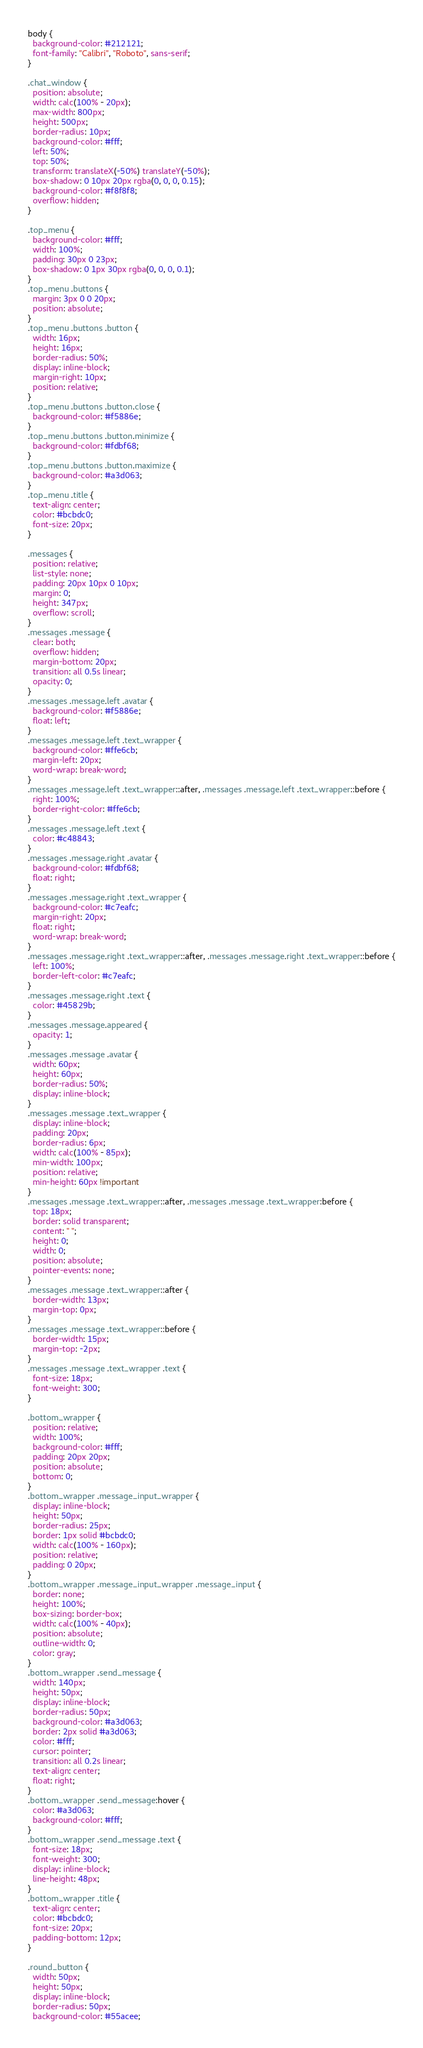Convert code to text. <code><loc_0><loc_0><loc_500><loc_500><_CSS_>body {
  background-color: #212121;
  font-family: "Calibri", "Roboto", sans-serif;
}

.chat_window {
  position: absolute;
  width: calc(100% - 20px);
  max-width: 800px;
  height: 500px;
  border-radius: 10px;
  background-color: #fff;
  left: 50%;
  top: 50%;
  transform: translateX(-50%) translateY(-50%);
  box-shadow: 0 10px 20px rgba(0, 0, 0, 0.15);
  background-color: #f8f8f8;
  overflow: hidden;
}

.top_menu {
  background-color: #fff;
  width: 100%;
  padding: 30px 0 23px;
  box-shadow: 0 1px 30px rgba(0, 0, 0, 0.1);
}
.top_menu .buttons {
  margin: 3px 0 0 20px;
  position: absolute;
}
.top_menu .buttons .button {
  width: 16px;
  height: 16px;
  border-radius: 50%;
  display: inline-block;
  margin-right: 10px;
  position: relative;
}
.top_menu .buttons .button.close {
  background-color: #f5886e;
}
.top_menu .buttons .button.minimize {
  background-color: #fdbf68;
}
.top_menu .buttons .button.maximize {
  background-color: #a3d063;
}
.top_menu .title {
  text-align: center;
  color: #bcbdc0;
  font-size: 20px;
}

.messages {
  position: relative;
  list-style: none;
  padding: 20px 10px 0 10px;
  margin: 0;
  height: 347px;
  overflow: scroll;
}
.messages .message {
  clear: both;
  overflow: hidden;
  margin-bottom: 20px;
  transition: all 0.5s linear;
  opacity: 0;
}
.messages .message.left .avatar {
  background-color: #f5886e;
  float: left;
}
.messages .message.left .text_wrapper {
  background-color: #ffe6cb;
  margin-left: 20px;
  word-wrap: break-word;
}
.messages .message.left .text_wrapper::after, .messages .message.left .text_wrapper::before {
  right: 100%;
  border-right-color: #ffe6cb;
}
.messages .message.left .text {
  color: #c48843;
}
.messages .message.right .avatar {
  background-color: #fdbf68;
  float: right;
}
.messages .message.right .text_wrapper {
  background-color: #c7eafc;
  margin-right: 20px;
  float: right;
  word-wrap: break-word;
}
.messages .message.right .text_wrapper::after, .messages .message.right .text_wrapper::before {
  left: 100%;
  border-left-color: #c7eafc;
}
.messages .message.right .text {
  color: #45829b;
}
.messages .message.appeared {
  opacity: 1;
}
.messages .message .avatar {
  width: 60px;
  height: 60px;
  border-radius: 50%;
  display: inline-block;
}
.messages .message .text_wrapper {
  display: inline-block;
  padding: 20px;
  border-radius: 6px;
  width: calc(100% - 85px);
  min-width: 100px;
  position: relative;
  min-height: 60px !important
}
.messages .message .text_wrapper::after, .messages .message .text_wrapper:before {
  top: 18px;
  border: solid transparent;
  content: " ";
  height: 0;
  width: 0;
  position: absolute;
  pointer-events: none;
}
.messages .message .text_wrapper::after {
  border-width: 13px;
  margin-top: 0px;
}
.messages .message .text_wrapper::before {
  border-width: 15px;
  margin-top: -2px;
}
.messages .message .text_wrapper .text {
  font-size: 18px;
  font-weight: 300;
}

.bottom_wrapper {
  position: relative;
  width: 100%;
  background-color: #fff;
  padding: 20px 20px;
  position: absolute;
  bottom: 0;
}
.bottom_wrapper .message_input_wrapper {
  display: inline-block;
  height: 50px;
  border-radius: 25px;
  border: 1px solid #bcbdc0;
  width: calc(100% - 160px);
  position: relative;
  padding: 0 20px;
}
.bottom_wrapper .message_input_wrapper .message_input {
  border: none;
  height: 100%;
  box-sizing: border-box;
  width: calc(100% - 40px);
  position: absolute;
  outline-width: 0;
  color: gray;
}
.bottom_wrapper .send_message {
  width: 140px;
  height: 50px;
  display: inline-block;
  border-radius: 50px;
  background-color: #a3d063;
  border: 2px solid #a3d063;
  color: #fff;
  cursor: pointer;
  transition: all 0.2s linear;
  text-align: center;
  float: right;
}
.bottom_wrapper .send_message:hover {
  color: #a3d063;
  background-color: #fff;
}
.bottom_wrapper .send_message .text {
  font-size: 18px;
  font-weight: 300;
  display: inline-block;
  line-height: 48px;
}
.bottom_wrapper .title {
  text-align: center;
  color: #bcbdc0;
  font-size: 20px;
  padding-bottom: 12px;
}

.round_button {
  width: 50px;
  height: 50px;
  display: inline-block;
  border-radius: 50px;
  background-color: #55acee;</code> 